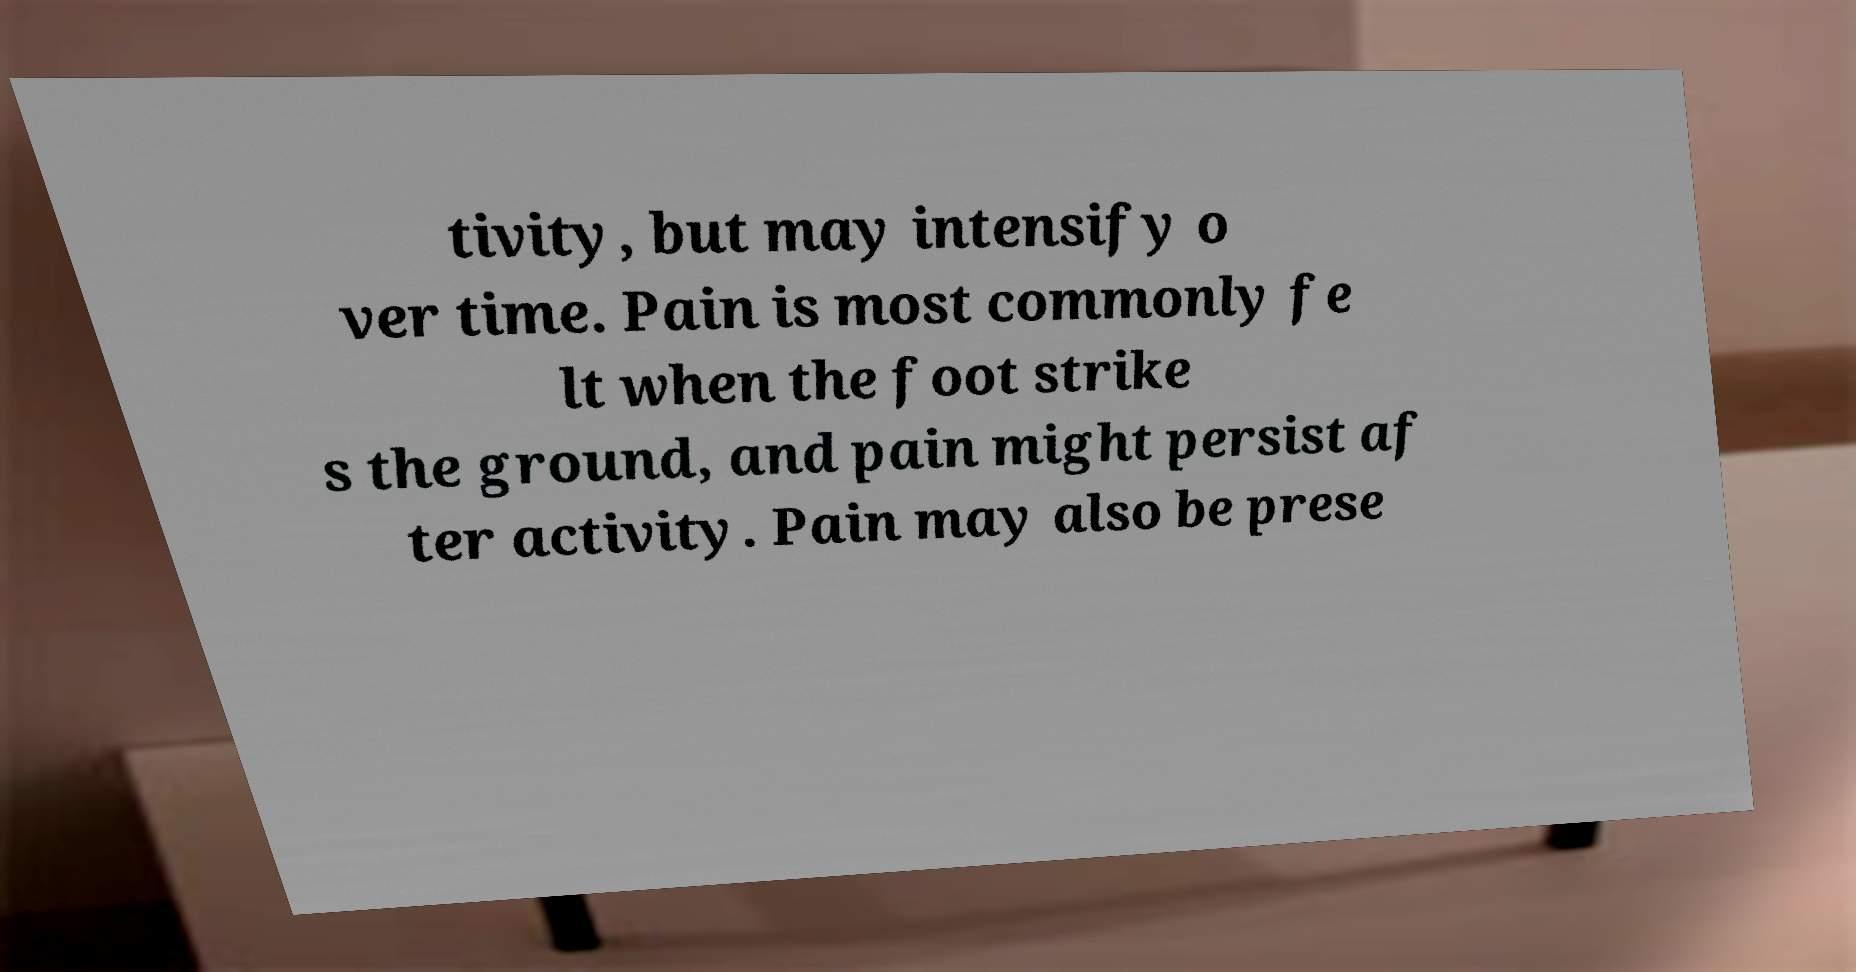Please read and relay the text visible in this image. What does it say? tivity, but may intensify o ver time. Pain is most commonly fe lt when the foot strike s the ground, and pain might persist af ter activity. Pain may also be prese 